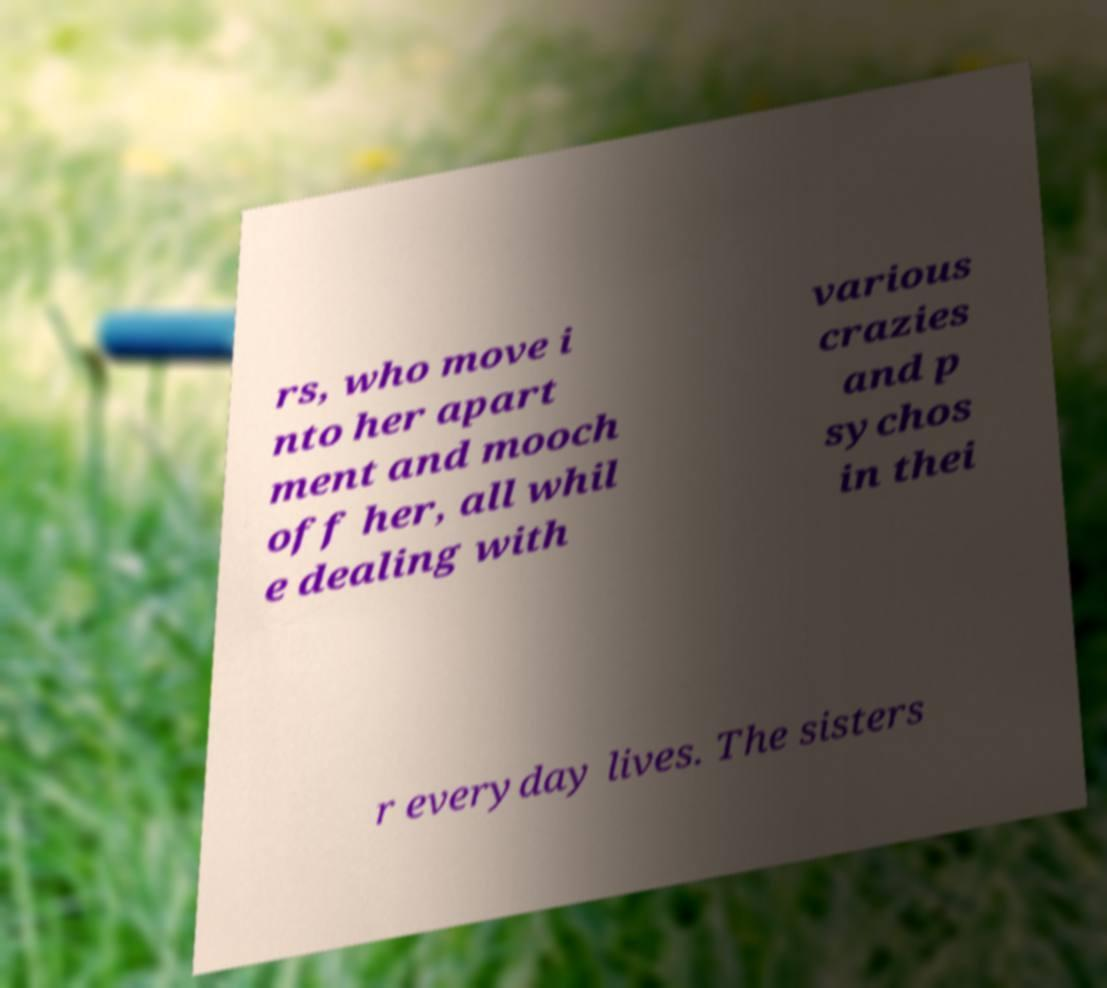Could you assist in decoding the text presented in this image and type it out clearly? rs, who move i nto her apart ment and mooch off her, all whil e dealing with various crazies and p sychos in thei r everyday lives. The sisters 